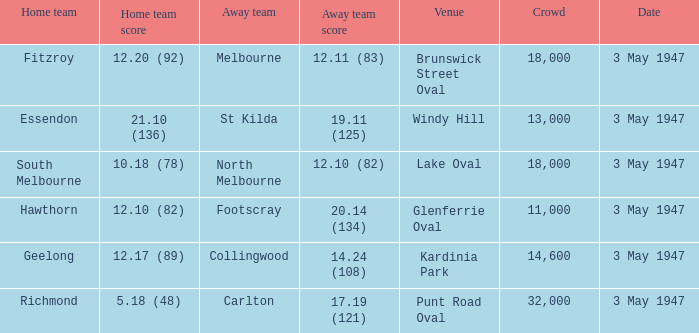In the game where the away team score is 17.19 (121), who was the away team? Carlton. 